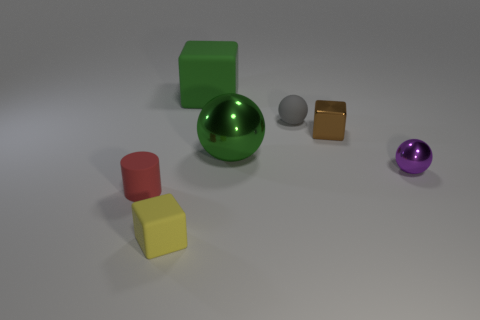Are there any rubber things that have the same color as the large ball?
Offer a very short reply. Yes. Do the rubber object on the right side of the green matte thing and the big rubber thing have the same size?
Provide a succinct answer. No. Are there an equal number of purple things in front of the purple thing and green metal things?
Make the answer very short. No. What number of objects are tiny matte things that are in front of the purple metallic sphere or purple shiny spheres?
Your answer should be compact. 3. What is the shape of the small thing that is in front of the tiny brown metal object and to the right of the small matte cube?
Provide a succinct answer. Sphere. How many objects are either green objects that are behind the large sphere or cubes that are behind the brown block?
Provide a succinct answer. 1. How many other objects are the same size as the yellow object?
Ensure brevity in your answer.  4. There is a big thing right of the big green cube; does it have the same color as the large rubber object?
Ensure brevity in your answer.  Yes. What size is the cube that is both on the left side of the brown block and behind the red cylinder?
Make the answer very short. Large. What number of small objects are rubber cylinders or rubber blocks?
Provide a succinct answer. 2. 